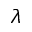Convert formula to latex. <formula><loc_0><loc_0><loc_500><loc_500>\lambda</formula> 